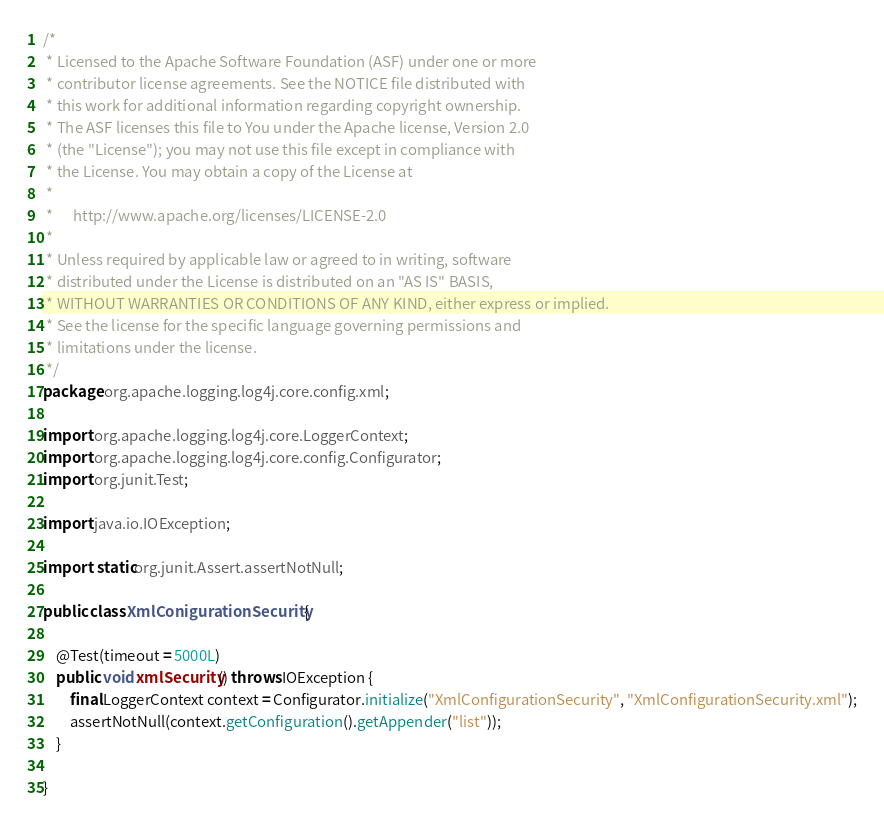<code> <loc_0><loc_0><loc_500><loc_500><_Java_>/*
 * Licensed to the Apache Software Foundation (ASF) under one or more
 * contributor license agreements. See the NOTICE file distributed with
 * this work for additional information regarding copyright ownership.
 * The ASF licenses this file to You under the Apache license, Version 2.0
 * (the "License"); you may not use this file except in compliance with
 * the License. You may obtain a copy of the License at
 *
 *      http://www.apache.org/licenses/LICENSE-2.0
 *
 * Unless required by applicable law or agreed to in writing, software
 * distributed under the License is distributed on an "AS IS" BASIS,
 * WITHOUT WARRANTIES OR CONDITIONS OF ANY KIND, either express or implied.
 * See the license for the specific language governing permissions and
 * limitations under the license.
 */
package org.apache.logging.log4j.core.config.xml;

import org.apache.logging.log4j.core.LoggerContext;
import org.apache.logging.log4j.core.config.Configurator;
import org.junit.Test;

import java.io.IOException;

import static org.junit.Assert.assertNotNull;

public class XmlConigurationSecurity {

    @Test(timeout = 5000L)
    public void xmlSecurity() throws IOException {
        final LoggerContext context = Configurator.initialize("XmlConfigurationSecurity", "XmlConfigurationSecurity.xml");
        assertNotNull(context.getConfiguration().getAppender("list"));
    }

}

</code> 